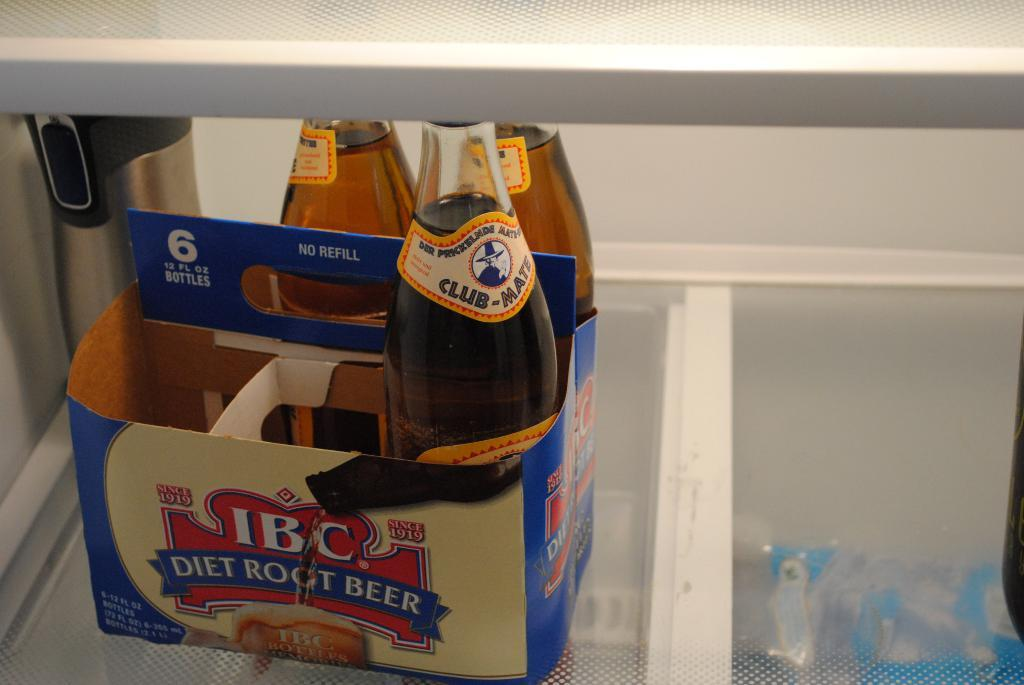Provide a one-sentence caption for the provided image. A box with three bottles of IBC diet root beer. 